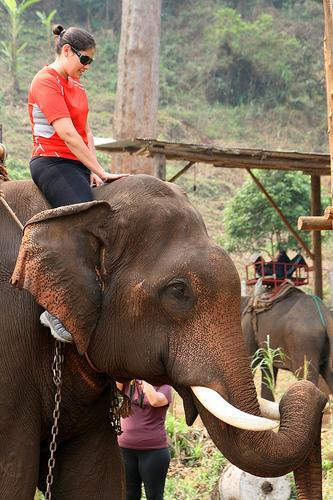Describe the footwear of the woman in the image, and its color. The woman is wearing a gray and blue tennis shoe. Identify the animal in the image, and describe any distinct features it possesses. An elephant with white tusks, a long trunk, large brown ear, and a chain wrapped around its neck. What can be seen wrapped around the elephant's neck, and what is its material? A chain is wrapped around the elephant's neck, made of metal with large links. What kind of setting is the image taken in, and what can be seen behind the elephant? The image is taken outside, possibly in hilly terrain with a deciduous tree and a wooden platform behind the elephant. Mention the primary activity in the image and where it is happening. A woman riding an elephant outdoors, possibly in a hilly terrain near a zoo exhibit. What type of clothing is the woman wearing and what is she doing on the animal? She is wearing a red short-sleeved shirt and black stretch pants, standing or riding on top of an elephant. Identify an accessory worn by the woman in the picture. The woman is wearing darkly tinted black sunglasses. What color is the woman's shirt, and what is she doing? The woman's shirt is red, and she is riding an elephant. List the key subjects and their prominent colors in the image. Woman with a red top, black pants, and purple shirt; an elephant with white tusks, a large brown ear, and a chain around its neck. What type of exhibit is the picture related to, and what animal does it involve? An elephant exhibit at a zoo, featuring an elephant with its rider. Is the woman wearing a green shirt? The instructions mention a red shirt, and a purple shirt, but there is no mention of a green shirt in the image. Is the woman wearing a hat during her elephant ride? There is no mention of a hat in the image. The woman is described as having a hair bun and wearing sunglasses, so the instruction about a hat is misleading. Can you see the zebra stripes on the elephant? There is no mention of zebra stripes on the elephant. It is simply described as "an elephant." Are there any fish swimming in a pond near the elephant? There is no mention of a pond or fish in the image, so this instruction is misleading. Can you find the dog in the picture? There is no mention of a dog in the image; only an elephant and a woman are described. Is the woman feeding the elephant an apple? There is no mention of the woman feeding the elephant or holding an apple in the image. 